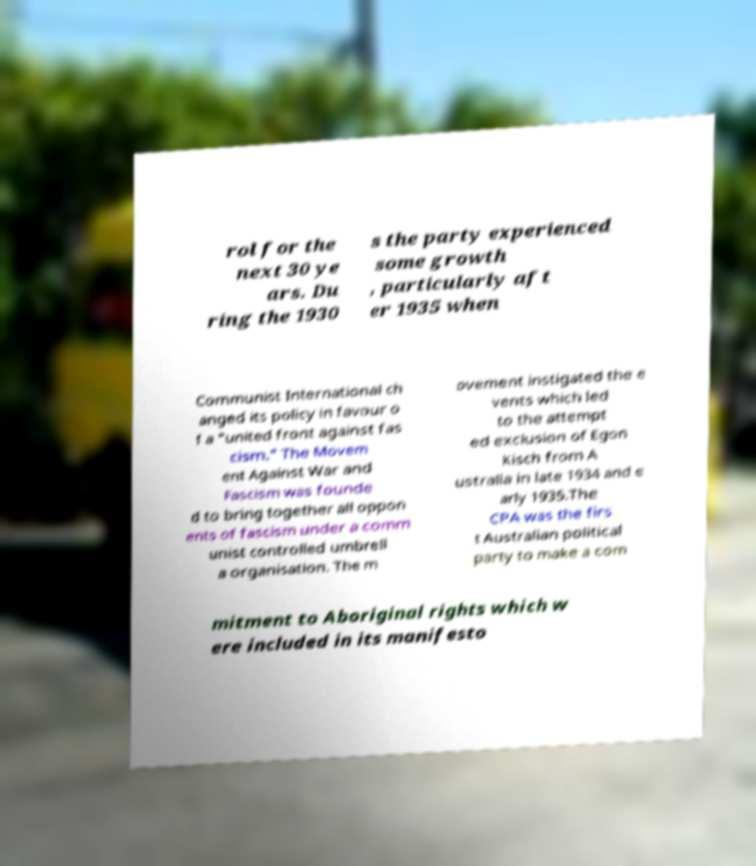Could you assist in decoding the text presented in this image and type it out clearly? rol for the next 30 ye ars. Du ring the 1930 s the party experienced some growth , particularly aft er 1935 when Communist International ch anged its policy in favour o f a "united front against fas cism." The Movem ent Against War and Fascism was founde d to bring together all oppon ents of fascism under a comm unist controlled umbrell a organisation. The m ovement instigated the e vents which led to the attempt ed exclusion of Egon Kisch from A ustralia in late 1934 and e arly 1935.The CPA was the firs t Australian political party to make a com mitment to Aboriginal rights which w ere included in its manifesto 